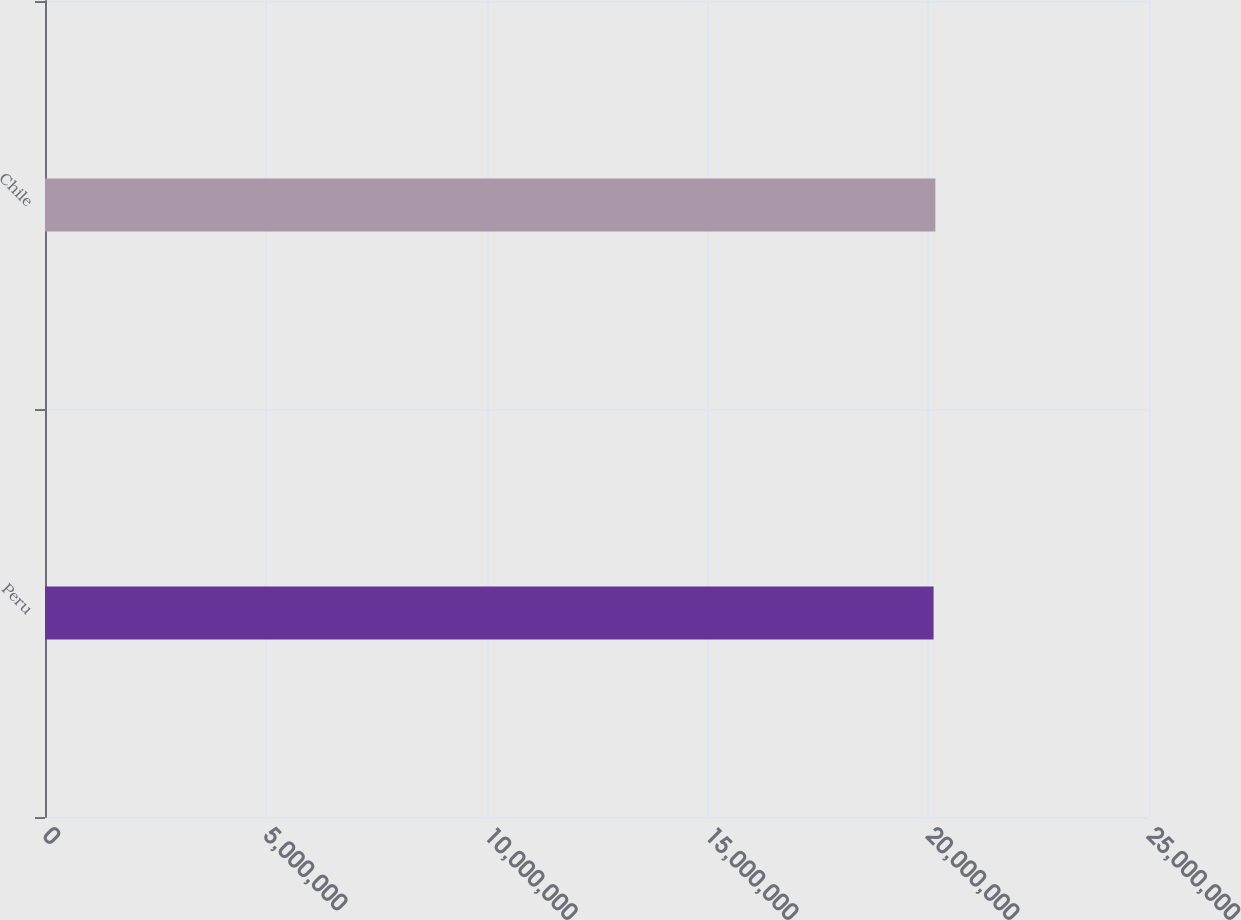Convert chart. <chart><loc_0><loc_0><loc_500><loc_500><bar_chart><fcel>Peru<fcel>Chile<nl><fcel>2.0122e+07<fcel>2.0162e+07<nl></chart> 